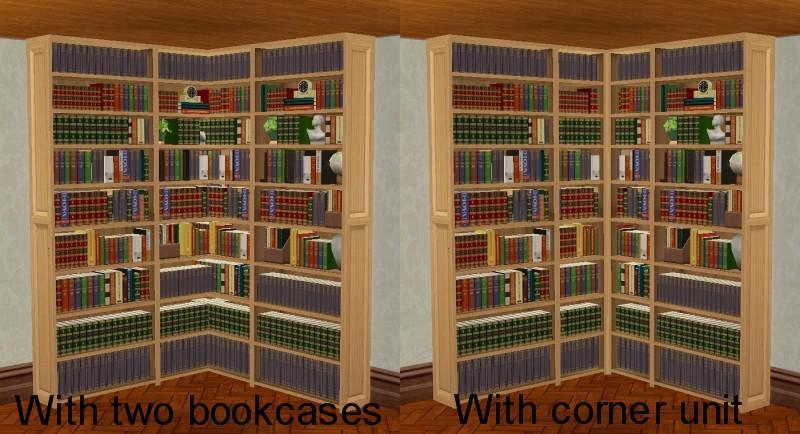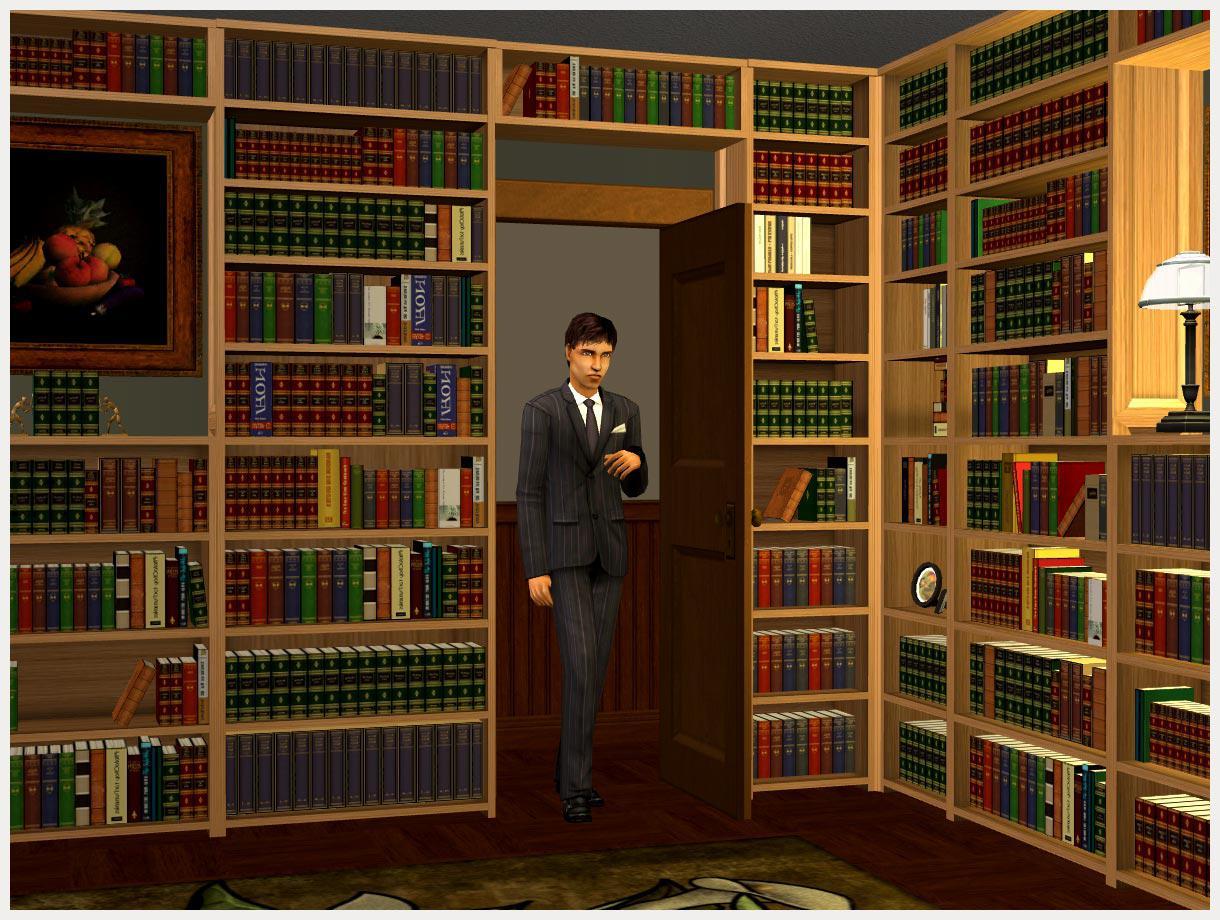The first image is the image on the left, the second image is the image on the right. For the images shown, is this caption "There is a desk in front of the bookcases in one of the images." true? Answer yes or no. No. 